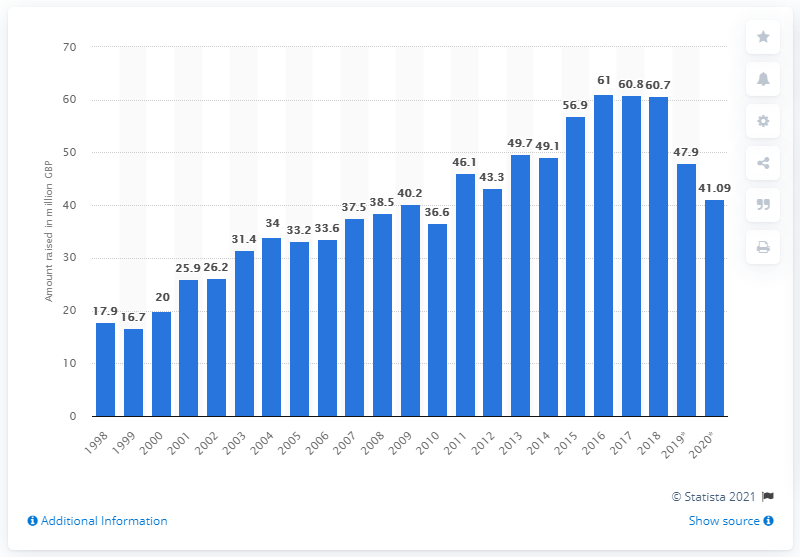Outline some significant characteristics in this image. The BBC's Children in Need appeal raised a total of 41.09 million. 